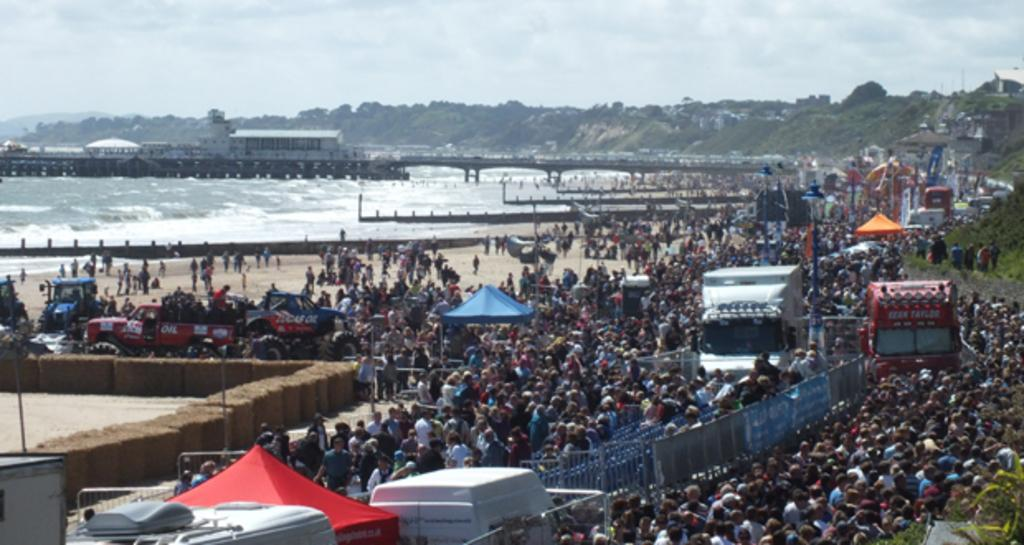What type of structure is present in the image? There is a bridge in the image. What natural element is visible in the image? There is water visible in the image. Can you describe the people in the image? There are people in the image. What type of geographical feature can be seen in the image? There are mountains in the image. What man-made objects are present in the image? There are vehicles in the image. What type of connection is being protested in the image? There is no protest or connection being depicted in the image; it features a bridge, water, people, mountains, and vehicles. What type of flesh can be seen on the people in the image? There is no flesh visible on the people in the image; it is a photograph, and the people are fully clothed. 